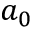<formula> <loc_0><loc_0><loc_500><loc_500>a _ { 0 }</formula> 